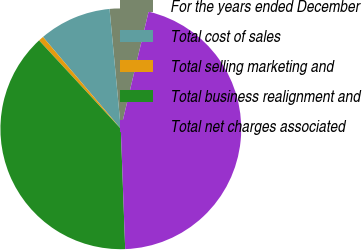Convert chart. <chart><loc_0><loc_0><loc_500><loc_500><pie_chart><fcel>For the years ended December<fcel>Total cost of sales<fcel>Total selling marketing and<fcel>Total business realignment and<fcel>Total net charges associated<nl><fcel>5.2%<fcel>9.7%<fcel>0.69%<fcel>38.7%<fcel>45.72%<nl></chart> 